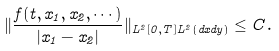Convert formula to latex. <formula><loc_0><loc_0><loc_500><loc_500>\| \frac { f ( t , x _ { 1 } , x _ { 2 } , \cdots ) } { | x _ { 1 } - x _ { 2 } | } \| _ { L ^ { 2 } [ 0 , T ] L ^ { 2 } ( d x d y ) } \leq C .</formula> 